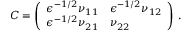<formula> <loc_0><loc_0><loc_500><loc_500>C = \left ( \begin{array} { l l } { \epsilon ^ { - 1 / 2 } \nu _ { 1 1 } } & { \epsilon ^ { - 1 / 2 } \nu _ { 1 2 } } \\ { \epsilon ^ { - 1 / 2 } \nu _ { 2 1 } } & { \nu _ { 2 2 } } \end{array} \right ) \, .</formula> 